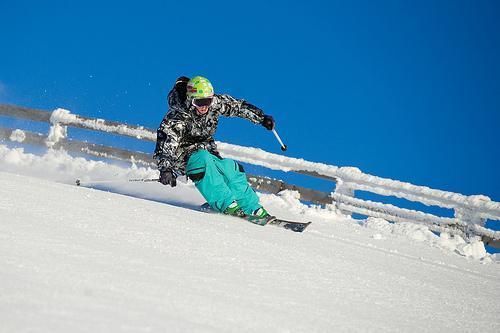How many people skiing?
Give a very brief answer. 1. 